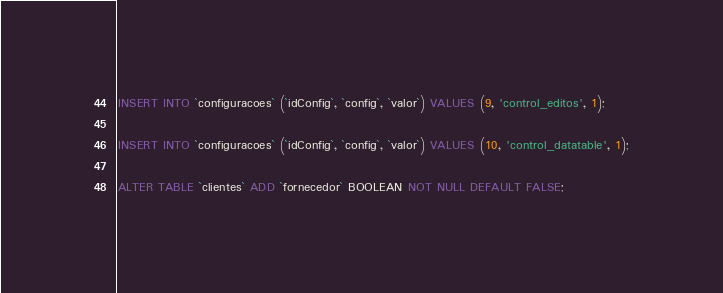<code> <loc_0><loc_0><loc_500><loc_500><_SQL_>INSERT INTO `configuracoes` (`idConfig`, `config`, `valor`) VALUES (9, 'control_editos', 1);

INSERT INTO `configuracoes` (`idConfig`, `config`, `valor`) VALUES (10, 'control_datatable', 1);

ALTER TABLE `clientes` ADD `fornecedor` BOOLEAN NOT NULL DEFAULT FALSE;
</code> 